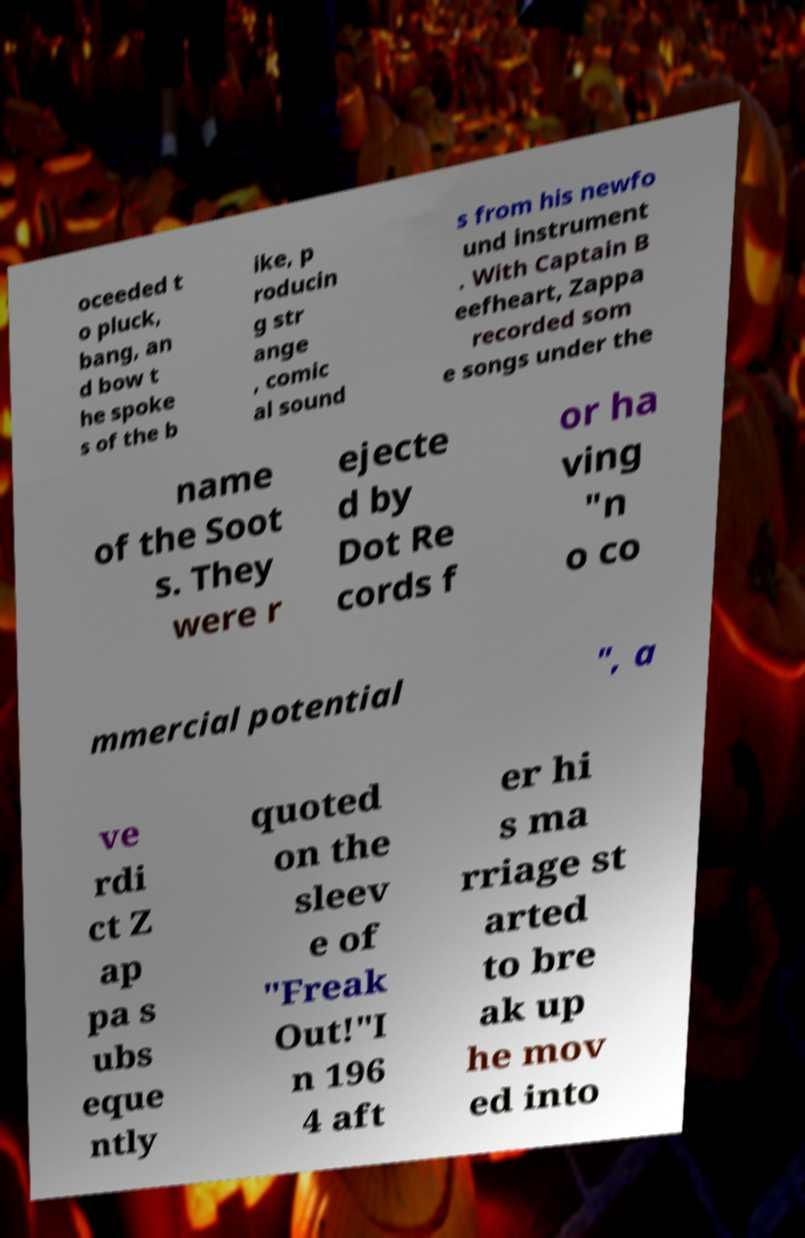There's text embedded in this image that I need extracted. Can you transcribe it verbatim? oceeded t o pluck, bang, an d bow t he spoke s of the b ike, p roducin g str ange , comic al sound s from his newfo und instrument . With Captain B eefheart, Zappa recorded som e songs under the name of the Soot s. They were r ejecte d by Dot Re cords f or ha ving "n o co mmercial potential ", a ve rdi ct Z ap pa s ubs eque ntly quoted on the sleev e of "Freak Out!"I n 196 4 aft er hi s ma rriage st arted to bre ak up he mov ed into 